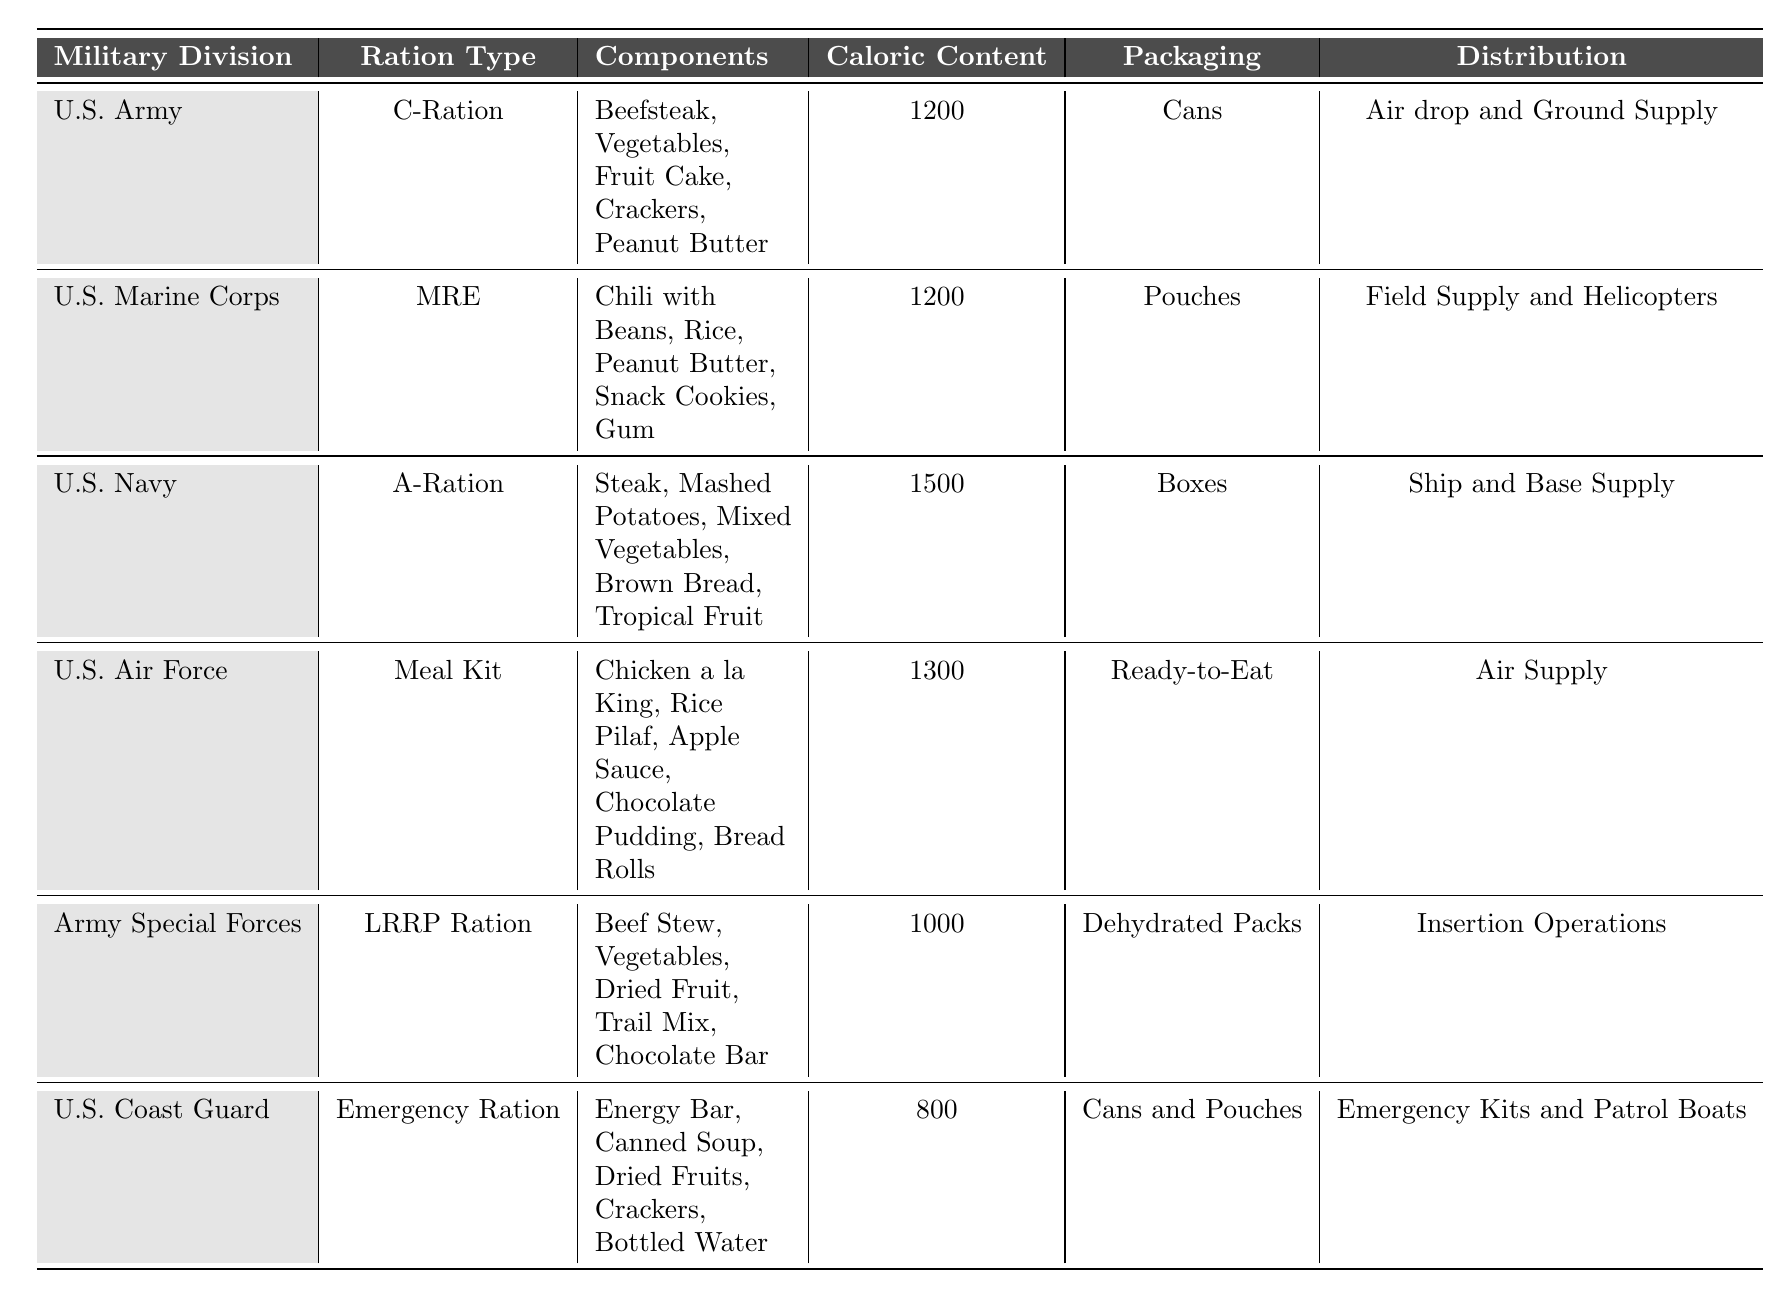What is the ration type provided to the U.S. Army? The table lists the U.S. Army's ration type as "C-Ration."
Answer: C-Ration Which military division has the highest caloric content in their rations? By comparing the caloric content values in the table, the U.S. Navy has the highest at 1500 calories.
Answer: U.S. Navy Do the U.S. Marine Corps rations contain peanut butter? The U.S. Marine Corps ration components include peanut butter, as stated in the table.
Answer: Yes What is the total caloric content of the rations provided by the U.S. Air Force and Army Special Forces combined? The U.S. Air Force has a caloric content of 1300 and the Army Special Forces has 1000 calories. Adding them (1300 + 1000) gives a total of 2300 calories.
Answer: 2300 True or False: The U.S. Coast Guard rations contain dried fruits. The table shows that the U.S. Coast Guard rations do include dried fruits in the components listed.
Answer: True What is the packaging type for the rations of the U.S. Navy? The packaging type for U.S. Navy rations is listed as "Boxes" in the table.
Answer: Boxes How many rations have a caloric content of 1200? Both the U.S. Army and U.S. Marine Corps rations have a caloric content of 1200, thus there are 2 rations with that caloric value.
Answer: 2 Identify the distribution method for the Emergency Ration of the U.S. Coast Guard. The table indicates that the distribution method for the U.S. Coast Guard's Emergency Ration is "Emergency Kits and Patrol Boats."
Answer: Emergency Kits and Patrol Boats What is the average caloric content of the rations provided by the U.S. Army, U.S. Marine Corps, and U.S. Air Force? The caloric contents for these divisions are 1200 (Army), 1200 (Marine Corps), and 1300 (Air Force). The sum is 3700, and dividing by 3 gives an average of 1233.33, which can be rounded to 1233.
Answer: 1233 Which division uses dehydrated packs for their rations? The table specifies that the Army Special Forces use "Dehydrated Packs" for their rations.
Answer: Army Special Forces 